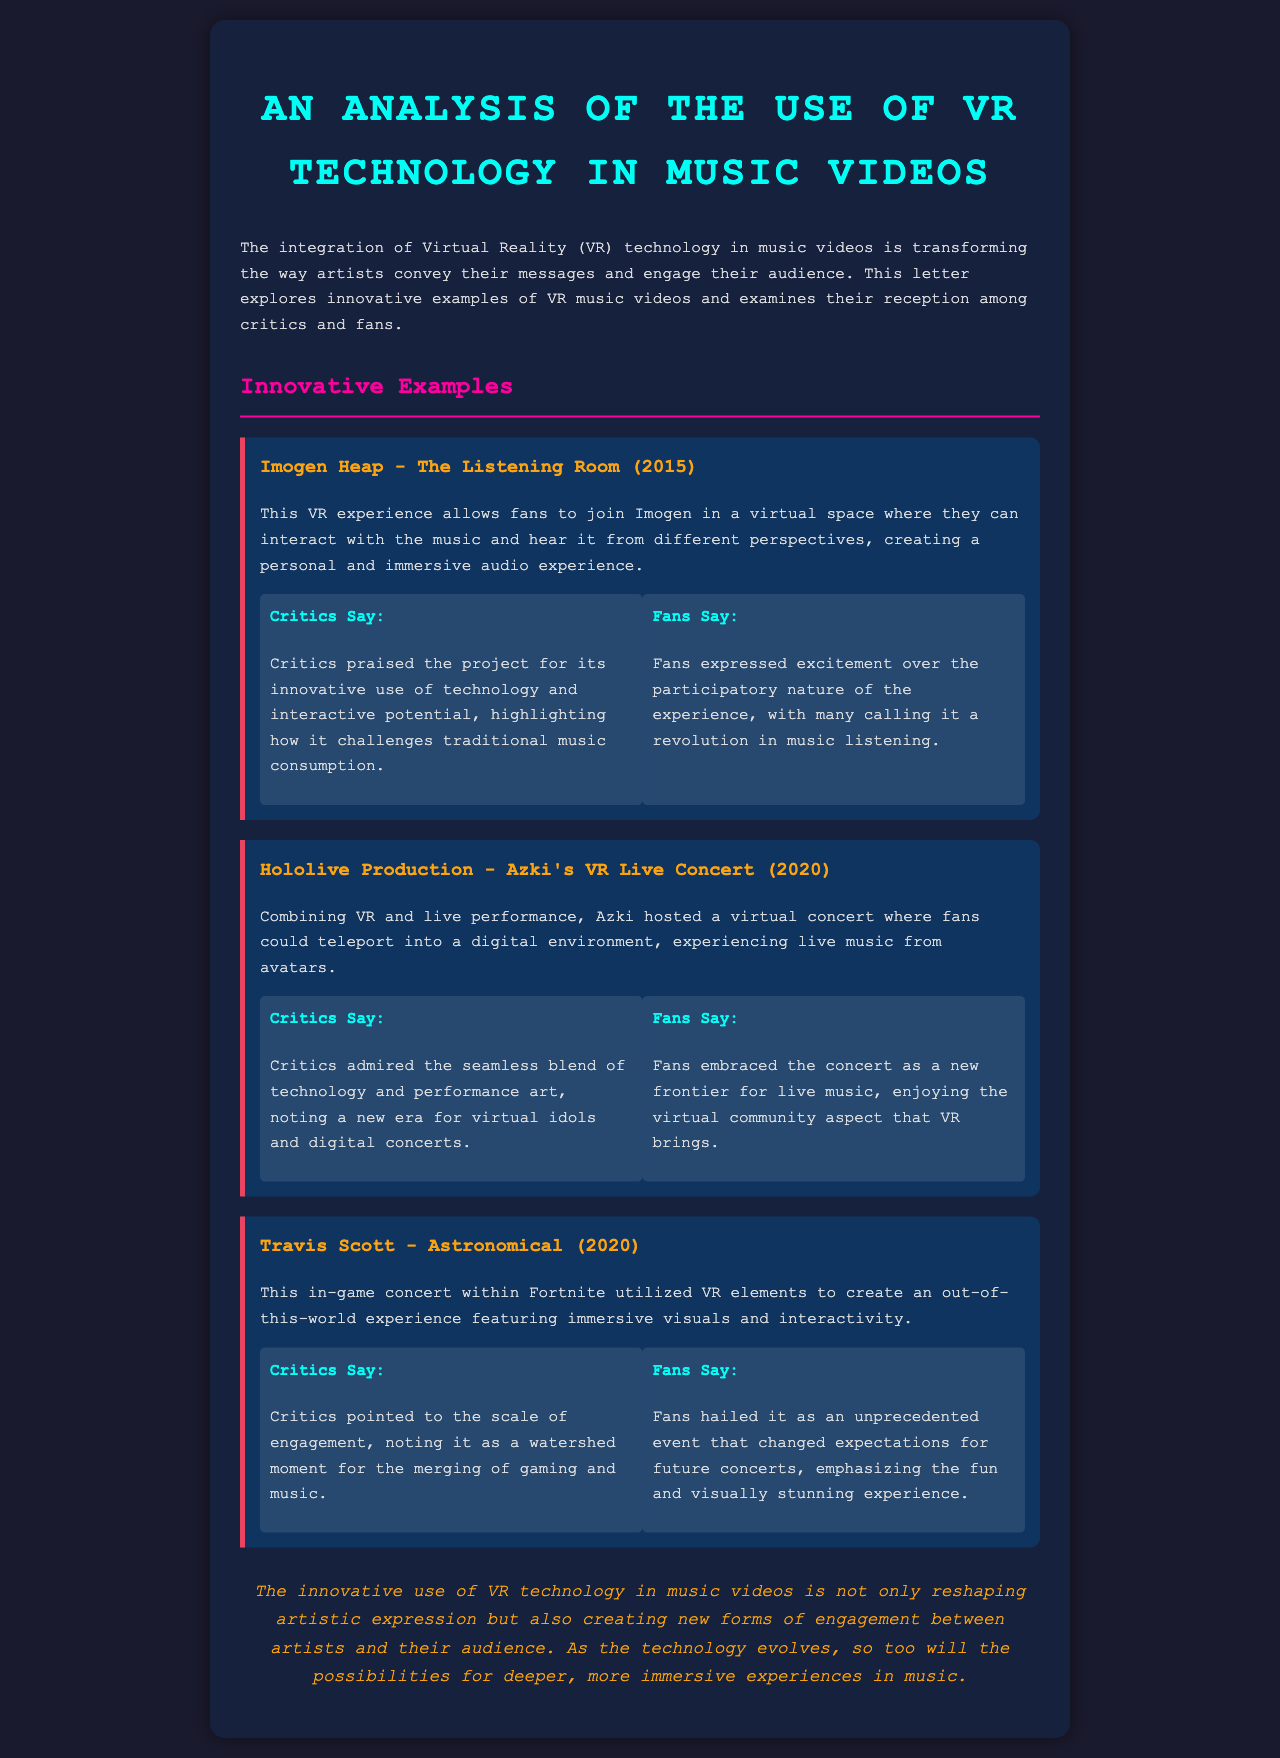what is the title of the letter? The title of the letter is stated in the header at the top of the document.
Answer: An Analysis of the Use of VR Technology in Music Videos who is the artist of "The Listening Room"? The letter explicitly names the artist associated with the VR experience mentioned.
Answer: Imogen Heap in what year did Azki's VR Live Concert take place? The year of Azki's VR Live Concert is mentioned alongside its title within the document.
Answer: 2020 what technology is primarily analyzed in this letter? The document focuses on a specific technology used in music videos as the main subject.
Answer: VR technology how do fans describe their experience of "Astronomical"? The document includes fans' reactions to the concert event in a specific phrase.
Answer: unprecedented event what do critics say about the use of VR in "The Listening Room"? The critics' opinion on the project highlights their view on its impact on traditional consumption.
Answer: innovative use of technology which game featured Travis Scott's virtual concert? The letter provides the name of the game where the concert took place.
Answer: Fortnite what is the overarching theme of the letter? The main theme of the document is reflected in how it describes the relationship between technology and music engagement.
Answer: immersive experiences in music 